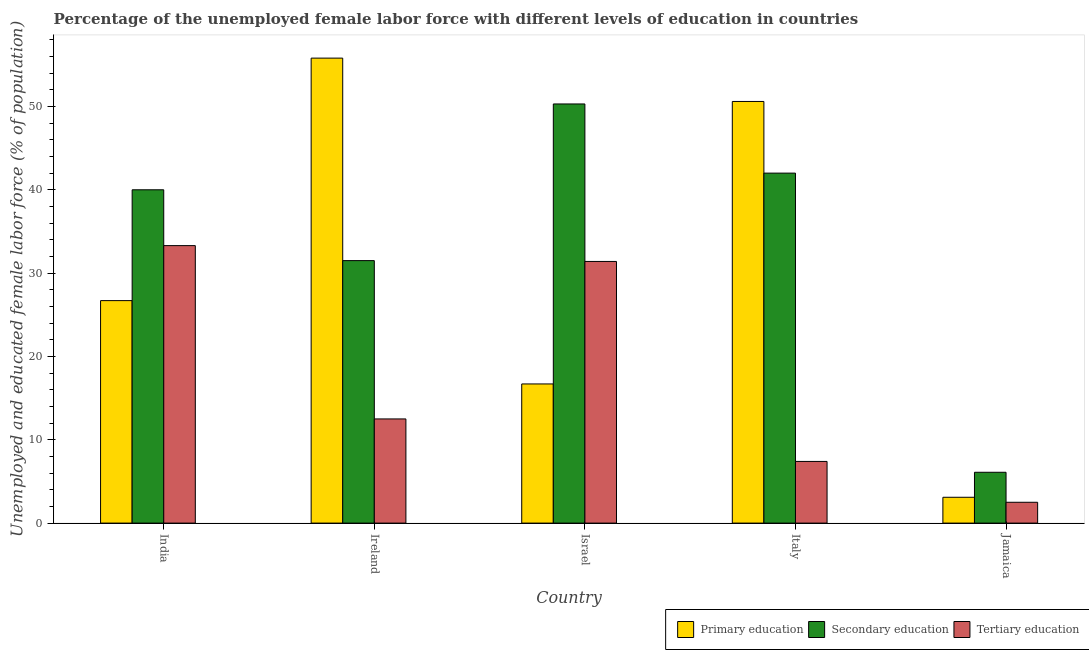How many bars are there on the 3rd tick from the left?
Provide a succinct answer. 3. How many bars are there on the 3rd tick from the right?
Give a very brief answer. 3. What is the label of the 2nd group of bars from the left?
Give a very brief answer. Ireland. What is the percentage of female labor force who received tertiary education in India?
Offer a very short reply. 33.3. Across all countries, what is the maximum percentage of female labor force who received primary education?
Ensure brevity in your answer.  55.8. Across all countries, what is the minimum percentage of female labor force who received secondary education?
Offer a terse response. 6.1. In which country was the percentage of female labor force who received primary education maximum?
Keep it short and to the point. Ireland. In which country was the percentage of female labor force who received primary education minimum?
Your answer should be very brief. Jamaica. What is the total percentage of female labor force who received primary education in the graph?
Offer a very short reply. 152.9. What is the difference between the percentage of female labor force who received tertiary education in Israel and that in Jamaica?
Offer a terse response. 28.9. What is the difference between the percentage of female labor force who received secondary education in Italy and the percentage of female labor force who received tertiary education in Ireland?
Offer a terse response. 29.5. What is the average percentage of female labor force who received primary education per country?
Provide a short and direct response. 30.58. What is the difference between the percentage of female labor force who received tertiary education and percentage of female labor force who received secondary education in Italy?
Make the answer very short. -34.6. In how many countries, is the percentage of female labor force who received primary education greater than 42 %?
Provide a succinct answer. 2. What is the ratio of the percentage of female labor force who received tertiary education in Italy to that in Jamaica?
Make the answer very short. 2.96. What is the difference between the highest and the second highest percentage of female labor force who received tertiary education?
Offer a very short reply. 1.9. What is the difference between the highest and the lowest percentage of female labor force who received tertiary education?
Your response must be concise. 30.8. In how many countries, is the percentage of female labor force who received tertiary education greater than the average percentage of female labor force who received tertiary education taken over all countries?
Your answer should be compact. 2. Is the sum of the percentage of female labor force who received primary education in Israel and Jamaica greater than the maximum percentage of female labor force who received secondary education across all countries?
Ensure brevity in your answer.  No. What does the 3rd bar from the left in Italy represents?
Your answer should be compact. Tertiary education. What does the 1st bar from the right in India represents?
Offer a very short reply. Tertiary education. Is it the case that in every country, the sum of the percentage of female labor force who received primary education and percentage of female labor force who received secondary education is greater than the percentage of female labor force who received tertiary education?
Your answer should be compact. Yes. Are all the bars in the graph horizontal?
Give a very brief answer. No. What is the difference between two consecutive major ticks on the Y-axis?
Provide a short and direct response. 10. Are the values on the major ticks of Y-axis written in scientific E-notation?
Your answer should be compact. No. Does the graph contain any zero values?
Ensure brevity in your answer.  No. Does the graph contain grids?
Keep it short and to the point. No. Where does the legend appear in the graph?
Give a very brief answer. Bottom right. How many legend labels are there?
Offer a terse response. 3. How are the legend labels stacked?
Your response must be concise. Horizontal. What is the title of the graph?
Your answer should be compact. Percentage of the unemployed female labor force with different levels of education in countries. Does "Machinery" appear as one of the legend labels in the graph?
Ensure brevity in your answer.  No. What is the label or title of the X-axis?
Ensure brevity in your answer.  Country. What is the label or title of the Y-axis?
Give a very brief answer. Unemployed and educated female labor force (% of population). What is the Unemployed and educated female labor force (% of population) in Primary education in India?
Provide a succinct answer. 26.7. What is the Unemployed and educated female labor force (% of population) in Secondary education in India?
Ensure brevity in your answer.  40. What is the Unemployed and educated female labor force (% of population) in Tertiary education in India?
Keep it short and to the point. 33.3. What is the Unemployed and educated female labor force (% of population) of Primary education in Ireland?
Your answer should be very brief. 55.8. What is the Unemployed and educated female labor force (% of population) in Secondary education in Ireland?
Your response must be concise. 31.5. What is the Unemployed and educated female labor force (% of population) of Tertiary education in Ireland?
Ensure brevity in your answer.  12.5. What is the Unemployed and educated female labor force (% of population) in Primary education in Israel?
Give a very brief answer. 16.7. What is the Unemployed and educated female labor force (% of population) in Secondary education in Israel?
Your answer should be compact. 50.3. What is the Unemployed and educated female labor force (% of population) in Tertiary education in Israel?
Your answer should be very brief. 31.4. What is the Unemployed and educated female labor force (% of population) in Primary education in Italy?
Your response must be concise. 50.6. What is the Unemployed and educated female labor force (% of population) of Secondary education in Italy?
Ensure brevity in your answer.  42. What is the Unemployed and educated female labor force (% of population) in Tertiary education in Italy?
Offer a very short reply. 7.4. What is the Unemployed and educated female labor force (% of population) in Primary education in Jamaica?
Your answer should be very brief. 3.1. What is the Unemployed and educated female labor force (% of population) of Secondary education in Jamaica?
Provide a succinct answer. 6.1. Across all countries, what is the maximum Unemployed and educated female labor force (% of population) of Primary education?
Your response must be concise. 55.8. Across all countries, what is the maximum Unemployed and educated female labor force (% of population) of Secondary education?
Keep it short and to the point. 50.3. Across all countries, what is the maximum Unemployed and educated female labor force (% of population) in Tertiary education?
Keep it short and to the point. 33.3. Across all countries, what is the minimum Unemployed and educated female labor force (% of population) in Primary education?
Provide a short and direct response. 3.1. Across all countries, what is the minimum Unemployed and educated female labor force (% of population) in Secondary education?
Provide a short and direct response. 6.1. What is the total Unemployed and educated female labor force (% of population) of Primary education in the graph?
Your answer should be compact. 152.9. What is the total Unemployed and educated female labor force (% of population) of Secondary education in the graph?
Give a very brief answer. 169.9. What is the total Unemployed and educated female labor force (% of population) in Tertiary education in the graph?
Your answer should be very brief. 87.1. What is the difference between the Unemployed and educated female labor force (% of population) in Primary education in India and that in Ireland?
Offer a very short reply. -29.1. What is the difference between the Unemployed and educated female labor force (% of population) in Secondary education in India and that in Ireland?
Make the answer very short. 8.5. What is the difference between the Unemployed and educated female labor force (% of population) in Tertiary education in India and that in Ireland?
Provide a short and direct response. 20.8. What is the difference between the Unemployed and educated female labor force (% of population) in Primary education in India and that in Italy?
Keep it short and to the point. -23.9. What is the difference between the Unemployed and educated female labor force (% of population) of Tertiary education in India and that in Italy?
Give a very brief answer. 25.9. What is the difference between the Unemployed and educated female labor force (% of population) in Primary education in India and that in Jamaica?
Provide a succinct answer. 23.6. What is the difference between the Unemployed and educated female labor force (% of population) of Secondary education in India and that in Jamaica?
Your answer should be very brief. 33.9. What is the difference between the Unemployed and educated female labor force (% of population) of Tertiary education in India and that in Jamaica?
Your answer should be compact. 30.8. What is the difference between the Unemployed and educated female labor force (% of population) of Primary education in Ireland and that in Israel?
Keep it short and to the point. 39.1. What is the difference between the Unemployed and educated female labor force (% of population) of Secondary education in Ireland and that in Israel?
Offer a very short reply. -18.8. What is the difference between the Unemployed and educated female labor force (% of population) of Tertiary education in Ireland and that in Israel?
Offer a very short reply. -18.9. What is the difference between the Unemployed and educated female labor force (% of population) in Primary education in Ireland and that in Italy?
Keep it short and to the point. 5.2. What is the difference between the Unemployed and educated female labor force (% of population) in Primary education in Ireland and that in Jamaica?
Your answer should be compact. 52.7. What is the difference between the Unemployed and educated female labor force (% of population) in Secondary education in Ireland and that in Jamaica?
Your answer should be compact. 25.4. What is the difference between the Unemployed and educated female labor force (% of population) of Tertiary education in Ireland and that in Jamaica?
Your response must be concise. 10. What is the difference between the Unemployed and educated female labor force (% of population) in Primary education in Israel and that in Italy?
Your answer should be compact. -33.9. What is the difference between the Unemployed and educated female labor force (% of population) of Secondary education in Israel and that in Italy?
Give a very brief answer. 8.3. What is the difference between the Unemployed and educated female labor force (% of population) of Primary education in Israel and that in Jamaica?
Your answer should be very brief. 13.6. What is the difference between the Unemployed and educated female labor force (% of population) of Secondary education in Israel and that in Jamaica?
Offer a very short reply. 44.2. What is the difference between the Unemployed and educated female labor force (% of population) in Tertiary education in Israel and that in Jamaica?
Your response must be concise. 28.9. What is the difference between the Unemployed and educated female labor force (% of population) of Primary education in Italy and that in Jamaica?
Your answer should be very brief. 47.5. What is the difference between the Unemployed and educated female labor force (% of population) of Secondary education in Italy and that in Jamaica?
Provide a short and direct response. 35.9. What is the difference between the Unemployed and educated female labor force (% of population) of Primary education in India and the Unemployed and educated female labor force (% of population) of Secondary education in Ireland?
Ensure brevity in your answer.  -4.8. What is the difference between the Unemployed and educated female labor force (% of population) of Secondary education in India and the Unemployed and educated female labor force (% of population) of Tertiary education in Ireland?
Make the answer very short. 27.5. What is the difference between the Unemployed and educated female labor force (% of population) in Primary education in India and the Unemployed and educated female labor force (% of population) in Secondary education in Israel?
Offer a very short reply. -23.6. What is the difference between the Unemployed and educated female labor force (% of population) of Primary education in India and the Unemployed and educated female labor force (% of population) of Tertiary education in Israel?
Keep it short and to the point. -4.7. What is the difference between the Unemployed and educated female labor force (% of population) in Primary education in India and the Unemployed and educated female labor force (% of population) in Secondary education in Italy?
Offer a terse response. -15.3. What is the difference between the Unemployed and educated female labor force (% of population) of Primary education in India and the Unemployed and educated female labor force (% of population) of Tertiary education in Italy?
Keep it short and to the point. 19.3. What is the difference between the Unemployed and educated female labor force (% of population) of Secondary education in India and the Unemployed and educated female labor force (% of population) of Tertiary education in Italy?
Your answer should be compact. 32.6. What is the difference between the Unemployed and educated female labor force (% of population) of Primary education in India and the Unemployed and educated female labor force (% of population) of Secondary education in Jamaica?
Ensure brevity in your answer.  20.6. What is the difference between the Unemployed and educated female labor force (% of population) in Primary education in India and the Unemployed and educated female labor force (% of population) in Tertiary education in Jamaica?
Keep it short and to the point. 24.2. What is the difference between the Unemployed and educated female labor force (% of population) in Secondary education in India and the Unemployed and educated female labor force (% of population) in Tertiary education in Jamaica?
Ensure brevity in your answer.  37.5. What is the difference between the Unemployed and educated female labor force (% of population) of Primary education in Ireland and the Unemployed and educated female labor force (% of population) of Secondary education in Israel?
Your response must be concise. 5.5. What is the difference between the Unemployed and educated female labor force (% of population) in Primary education in Ireland and the Unemployed and educated female labor force (% of population) in Tertiary education in Israel?
Your answer should be very brief. 24.4. What is the difference between the Unemployed and educated female labor force (% of population) of Primary education in Ireland and the Unemployed and educated female labor force (% of population) of Secondary education in Italy?
Provide a succinct answer. 13.8. What is the difference between the Unemployed and educated female labor force (% of population) in Primary education in Ireland and the Unemployed and educated female labor force (% of population) in Tertiary education in Italy?
Your answer should be very brief. 48.4. What is the difference between the Unemployed and educated female labor force (% of population) of Secondary education in Ireland and the Unemployed and educated female labor force (% of population) of Tertiary education in Italy?
Ensure brevity in your answer.  24.1. What is the difference between the Unemployed and educated female labor force (% of population) of Primary education in Ireland and the Unemployed and educated female labor force (% of population) of Secondary education in Jamaica?
Make the answer very short. 49.7. What is the difference between the Unemployed and educated female labor force (% of population) of Primary education in Ireland and the Unemployed and educated female labor force (% of population) of Tertiary education in Jamaica?
Your answer should be very brief. 53.3. What is the difference between the Unemployed and educated female labor force (% of population) in Secondary education in Ireland and the Unemployed and educated female labor force (% of population) in Tertiary education in Jamaica?
Provide a succinct answer. 29. What is the difference between the Unemployed and educated female labor force (% of population) in Primary education in Israel and the Unemployed and educated female labor force (% of population) in Secondary education in Italy?
Provide a short and direct response. -25.3. What is the difference between the Unemployed and educated female labor force (% of population) in Secondary education in Israel and the Unemployed and educated female labor force (% of population) in Tertiary education in Italy?
Ensure brevity in your answer.  42.9. What is the difference between the Unemployed and educated female labor force (% of population) in Secondary education in Israel and the Unemployed and educated female labor force (% of population) in Tertiary education in Jamaica?
Your answer should be compact. 47.8. What is the difference between the Unemployed and educated female labor force (% of population) of Primary education in Italy and the Unemployed and educated female labor force (% of population) of Secondary education in Jamaica?
Offer a terse response. 44.5. What is the difference between the Unemployed and educated female labor force (% of population) of Primary education in Italy and the Unemployed and educated female labor force (% of population) of Tertiary education in Jamaica?
Provide a short and direct response. 48.1. What is the difference between the Unemployed and educated female labor force (% of population) of Secondary education in Italy and the Unemployed and educated female labor force (% of population) of Tertiary education in Jamaica?
Offer a terse response. 39.5. What is the average Unemployed and educated female labor force (% of population) of Primary education per country?
Provide a succinct answer. 30.58. What is the average Unemployed and educated female labor force (% of population) in Secondary education per country?
Your answer should be very brief. 33.98. What is the average Unemployed and educated female labor force (% of population) in Tertiary education per country?
Your response must be concise. 17.42. What is the difference between the Unemployed and educated female labor force (% of population) of Primary education and Unemployed and educated female labor force (% of population) of Tertiary education in India?
Offer a terse response. -6.6. What is the difference between the Unemployed and educated female labor force (% of population) of Secondary education and Unemployed and educated female labor force (% of population) of Tertiary education in India?
Offer a very short reply. 6.7. What is the difference between the Unemployed and educated female labor force (% of population) of Primary education and Unemployed and educated female labor force (% of population) of Secondary education in Ireland?
Ensure brevity in your answer.  24.3. What is the difference between the Unemployed and educated female labor force (% of population) of Primary education and Unemployed and educated female labor force (% of population) of Tertiary education in Ireland?
Provide a succinct answer. 43.3. What is the difference between the Unemployed and educated female labor force (% of population) of Primary education and Unemployed and educated female labor force (% of population) of Secondary education in Israel?
Make the answer very short. -33.6. What is the difference between the Unemployed and educated female labor force (% of population) of Primary education and Unemployed and educated female labor force (% of population) of Tertiary education in Israel?
Provide a succinct answer. -14.7. What is the difference between the Unemployed and educated female labor force (% of population) of Secondary education and Unemployed and educated female labor force (% of population) of Tertiary education in Israel?
Keep it short and to the point. 18.9. What is the difference between the Unemployed and educated female labor force (% of population) in Primary education and Unemployed and educated female labor force (% of population) in Secondary education in Italy?
Offer a terse response. 8.6. What is the difference between the Unemployed and educated female labor force (% of population) of Primary education and Unemployed and educated female labor force (% of population) of Tertiary education in Italy?
Your response must be concise. 43.2. What is the difference between the Unemployed and educated female labor force (% of population) in Secondary education and Unemployed and educated female labor force (% of population) in Tertiary education in Italy?
Give a very brief answer. 34.6. What is the difference between the Unemployed and educated female labor force (% of population) in Primary education and Unemployed and educated female labor force (% of population) in Tertiary education in Jamaica?
Provide a short and direct response. 0.6. What is the difference between the Unemployed and educated female labor force (% of population) in Secondary education and Unemployed and educated female labor force (% of population) in Tertiary education in Jamaica?
Your response must be concise. 3.6. What is the ratio of the Unemployed and educated female labor force (% of population) in Primary education in India to that in Ireland?
Ensure brevity in your answer.  0.48. What is the ratio of the Unemployed and educated female labor force (% of population) in Secondary education in India to that in Ireland?
Offer a terse response. 1.27. What is the ratio of the Unemployed and educated female labor force (% of population) of Tertiary education in India to that in Ireland?
Provide a short and direct response. 2.66. What is the ratio of the Unemployed and educated female labor force (% of population) of Primary education in India to that in Israel?
Make the answer very short. 1.6. What is the ratio of the Unemployed and educated female labor force (% of population) in Secondary education in India to that in Israel?
Offer a very short reply. 0.8. What is the ratio of the Unemployed and educated female labor force (% of population) of Tertiary education in India to that in Israel?
Your answer should be compact. 1.06. What is the ratio of the Unemployed and educated female labor force (% of population) in Primary education in India to that in Italy?
Provide a succinct answer. 0.53. What is the ratio of the Unemployed and educated female labor force (% of population) in Primary education in India to that in Jamaica?
Your answer should be compact. 8.61. What is the ratio of the Unemployed and educated female labor force (% of population) in Secondary education in India to that in Jamaica?
Your answer should be compact. 6.56. What is the ratio of the Unemployed and educated female labor force (% of population) in Tertiary education in India to that in Jamaica?
Offer a very short reply. 13.32. What is the ratio of the Unemployed and educated female labor force (% of population) in Primary education in Ireland to that in Israel?
Your answer should be compact. 3.34. What is the ratio of the Unemployed and educated female labor force (% of population) of Secondary education in Ireland to that in Israel?
Provide a short and direct response. 0.63. What is the ratio of the Unemployed and educated female labor force (% of population) in Tertiary education in Ireland to that in Israel?
Give a very brief answer. 0.4. What is the ratio of the Unemployed and educated female labor force (% of population) of Primary education in Ireland to that in Italy?
Ensure brevity in your answer.  1.1. What is the ratio of the Unemployed and educated female labor force (% of population) of Secondary education in Ireland to that in Italy?
Provide a short and direct response. 0.75. What is the ratio of the Unemployed and educated female labor force (% of population) of Tertiary education in Ireland to that in Italy?
Your answer should be very brief. 1.69. What is the ratio of the Unemployed and educated female labor force (% of population) of Secondary education in Ireland to that in Jamaica?
Your response must be concise. 5.16. What is the ratio of the Unemployed and educated female labor force (% of population) of Primary education in Israel to that in Italy?
Keep it short and to the point. 0.33. What is the ratio of the Unemployed and educated female labor force (% of population) in Secondary education in Israel to that in Italy?
Offer a terse response. 1.2. What is the ratio of the Unemployed and educated female labor force (% of population) in Tertiary education in Israel to that in Italy?
Make the answer very short. 4.24. What is the ratio of the Unemployed and educated female labor force (% of population) in Primary education in Israel to that in Jamaica?
Your response must be concise. 5.39. What is the ratio of the Unemployed and educated female labor force (% of population) in Secondary education in Israel to that in Jamaica?
Make the answer very short. 8.25. What is the ratio of the Unemployed and educated female labor force (% of population) of Tertiary education in Israel to that in Jamaica?
Offer a terse response. 12.56. What is the ratio of the Unemployed and educated female labor force (% of population) of Primary education in Italy to that in Jamaica?
Your answer should be compact. 16.32. What is the ratio of the Unemployed and educated female labor force (% of population) of Secondary education in Italy to that in Jamaica?
Make the answer very short. 6.89. What is the ratio of the Unemployed and educated female labor force (% of population) of Tertiary education in Italy to that in Jamaica?
Your answer should be very brief. 2.96. What is the difference between the highest and the lowest Unemployed and educated female labor force (% of population) of Primary education?
Provide a succinct answer. 52.7. What is the difference between the highest and the lowest Unemployed and educated female labor force (% of population) of Secondary education?
Offer a terse response. 44.2. What is the difference between the highest and the lowest Unemployed and educated female labor force (% of population) of Tertiary education?
Your answer should be very brief. 30.8. 